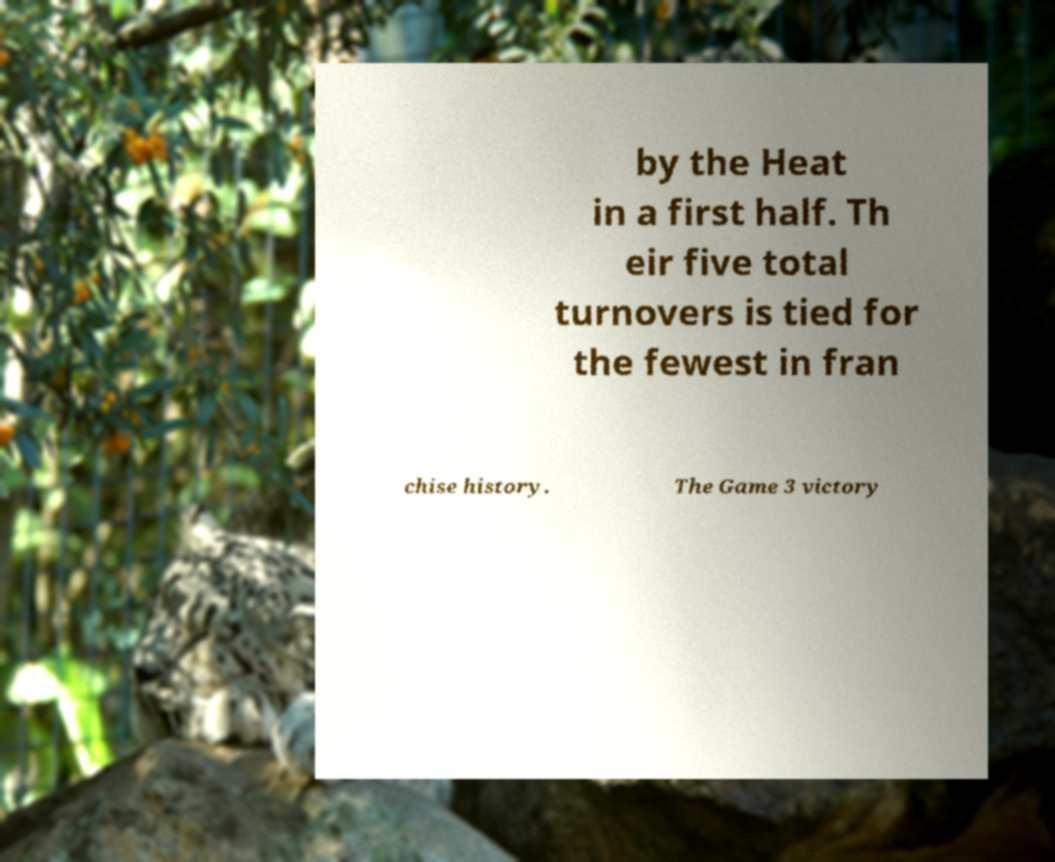Can you read and provide the text displayed in the image?This photo seems to have some interesting text. Can you extract and type it out for me? by the Heat in a first half. Th eir five total turnovers is tied for the fewest in fran chise history. The Game 3 victory 